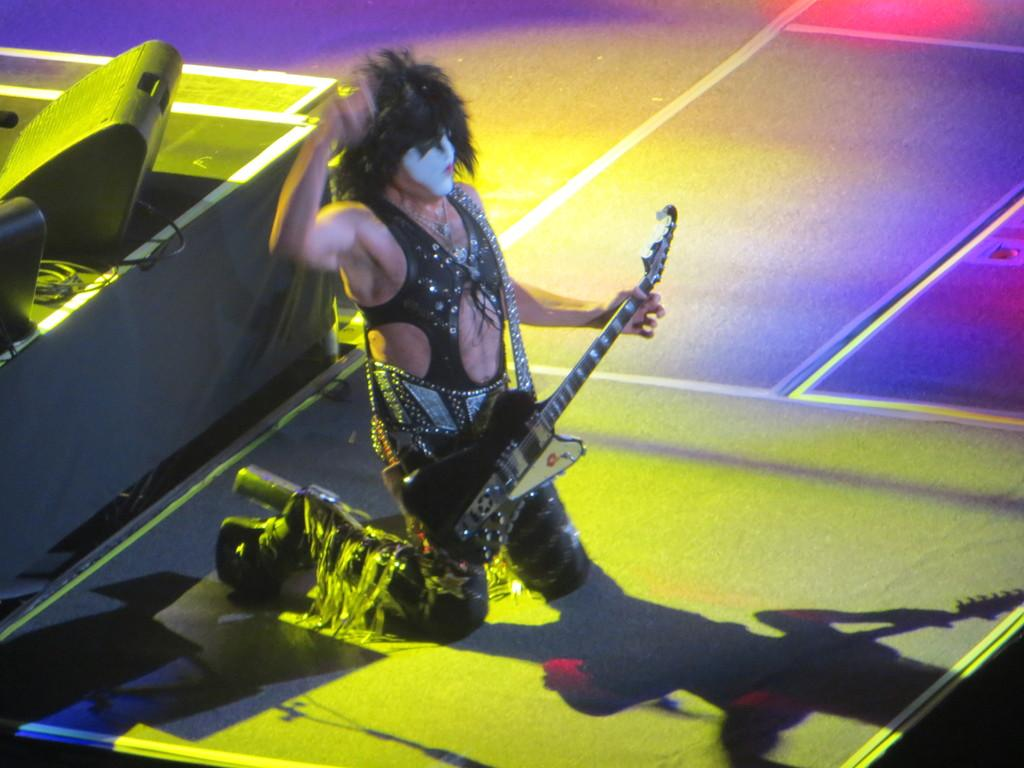What is the main subject of the image? There is a person in the image. What is the person doing in the image? The person is on a kneeling position and holding a guitar. How is the person's face decorated in the image? The person's face is painted. What can be seen on the left side of the image? There is a stand on the left side of the image. What is on the stand in the image? There are speakers on the stand. Can you see any crows flying over the person's head in the image? There are no crows visible in the image. Is the person wearing a veil over their face in the image? The person's face is painted, but there is no mention of a veil in the image. --- Facts: 1. There is a car in the image. 2. The car is red. 3. The car has four wheels. 4. There are people in the car. 5. The car is parked on the street. Absurd Topics: parrot, sand, volcano Conversation: What is the main subject of the image? There is a car in the image. What color is the car? The car is red. How many wheels does the car have? The car has four wheels. Are there any passengers in the car? Yes, there are people in the car. Where is the car located in the image? The car is parked on the street. Reasoning: Let's think step by step in order to produce the conversation. We start by identifying the main subject of the image, which is the car. Then, we describe the car's color and number of wheels. Next, we mention the presence of passengers in the car. Finally, we describe the car's location, which is parked on the street. Each question is designed to elicit a specific detail about the image that is known from the provided facts. Absurd Question/Answer: Can you see any parrots sitting on the car's roof in the image? There are no parrots visible in the image. Is the car parked near a volcano in the image? There is no mention of a volcano in the image. 